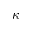<formula> <loc_0><loc_0><loc_500><loc_500>\kappa</formula> 